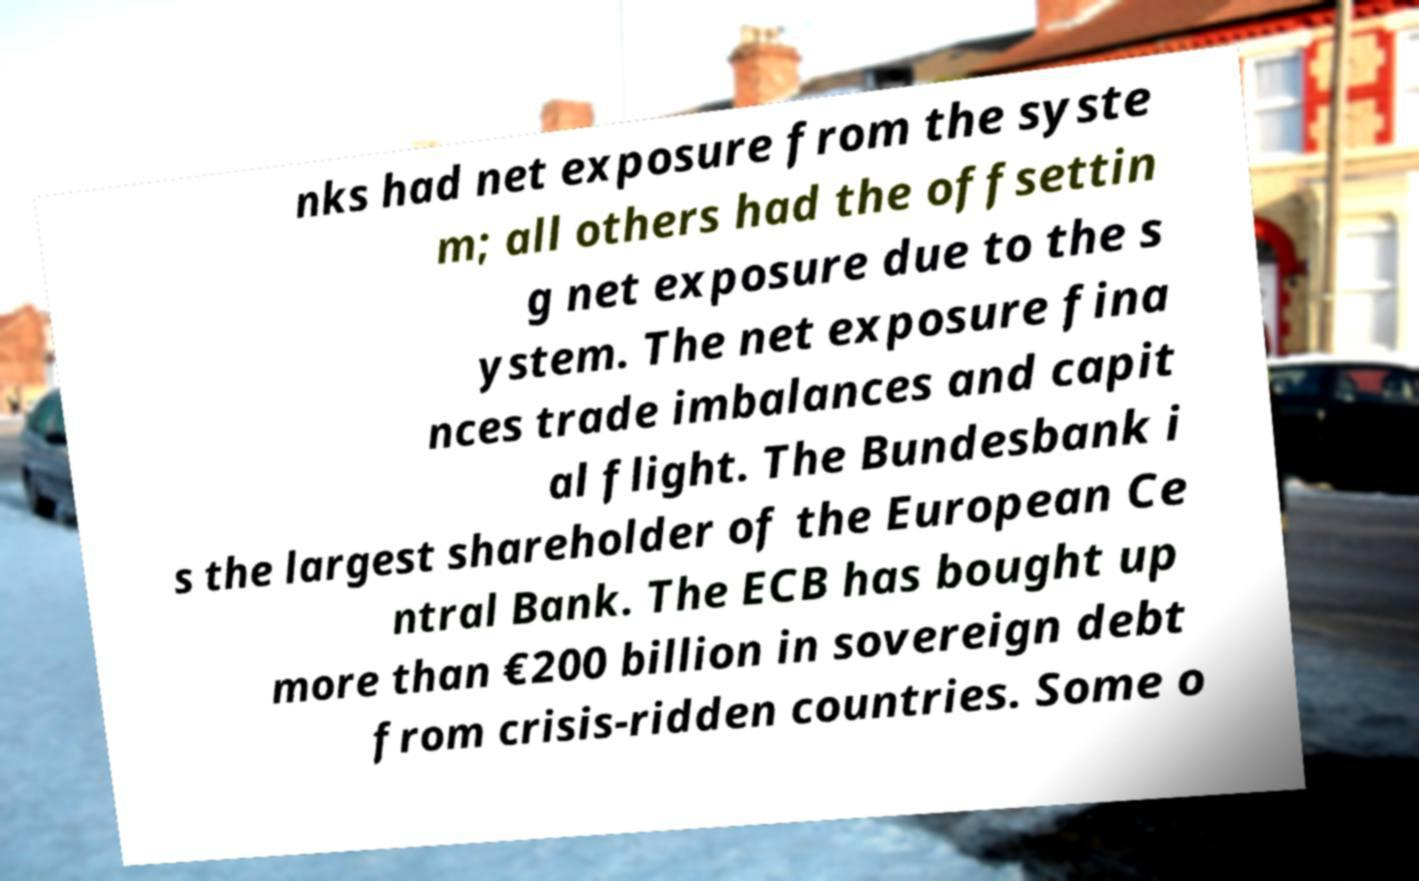For documentation purposes, I need the text within this image transcribed. Could you provide that? nks had net exposure from the syste m; all others had the offsettin g net exposure due to the s ystem. The net exposure fina nces trade imbalances and capit al flight. The Bundesbank i s the largest shareholder of the European Ce ntral Bank. The ECB has bought up more than €200 billion in sovereign debt from crisis-ridden countries. Some o 